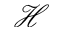<formula> <loc_0><loc_0><loc_500><loc_500>\mathcal { H }</formula> 